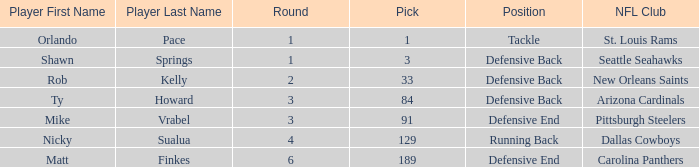What lowest round has orlando pace as the player? 1.0. 